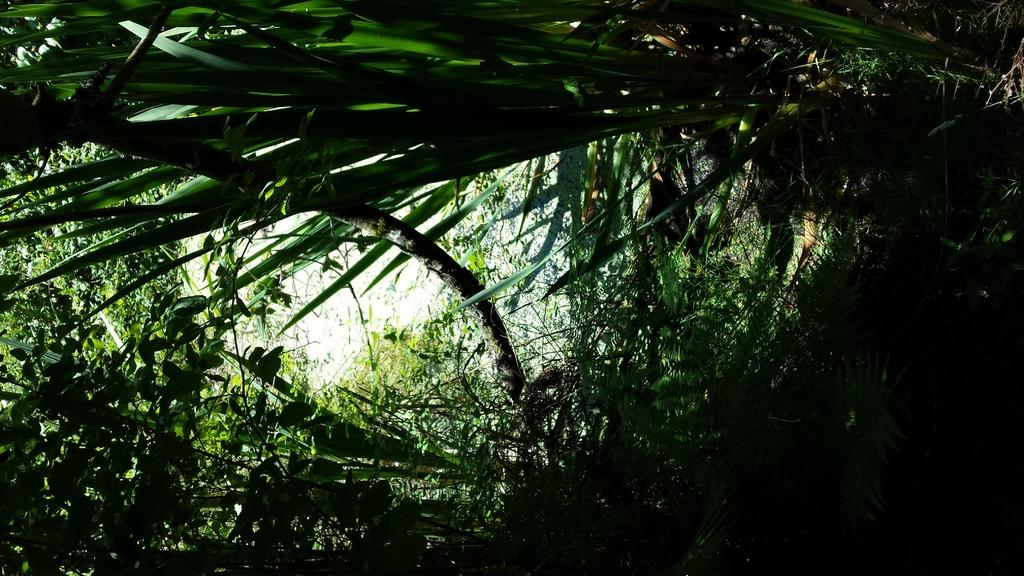What type of vegetation can be seen in the image? There are trees in the image. What part of the trees can be seen in the image? There are leaves in the image. What is visible at the top of the image? The sky is visible at the top of the image, and it is clear. Can you tell me how many feet are visible in the image? There are no feet present in the image; it features trees, leaves, and a clear sky. What type of lipstick is being used by the tree in the image? There is no lipstick or tree using lipstick present in the image. 